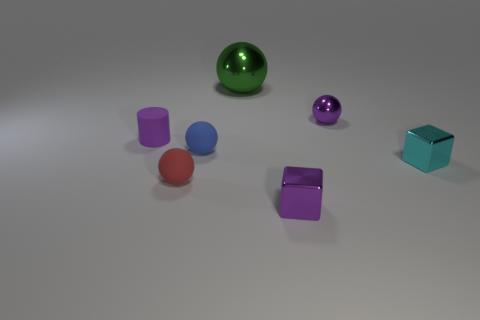Add 1 blue matte objects. How many objects exist? 8 Subtract all blocks. How many objects are left? 5 Add 5 large purple matte blocks. How many large purple matte blocks exist? 5 Subtract 0 cyan cylinders. How many objects are left? 7 Subtract all yellow cylinders. Subtract all small cyan things. How many objects are left? 6 Add 5 red spheres. How many red spheres are left? 6 